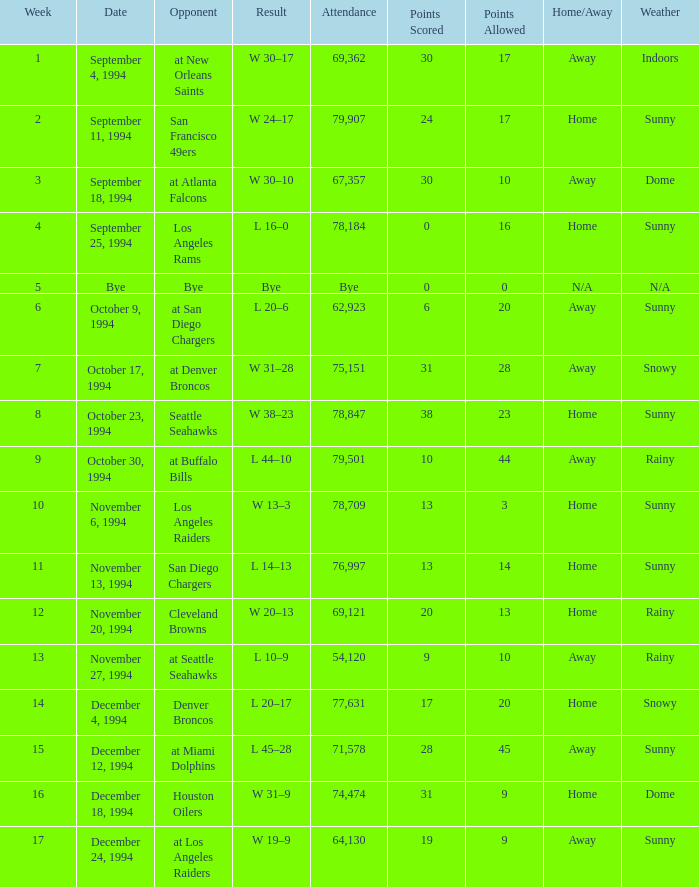What was the score of the Chiefs pre-Week 16 game that 69,362 people attended? W 30–17. 